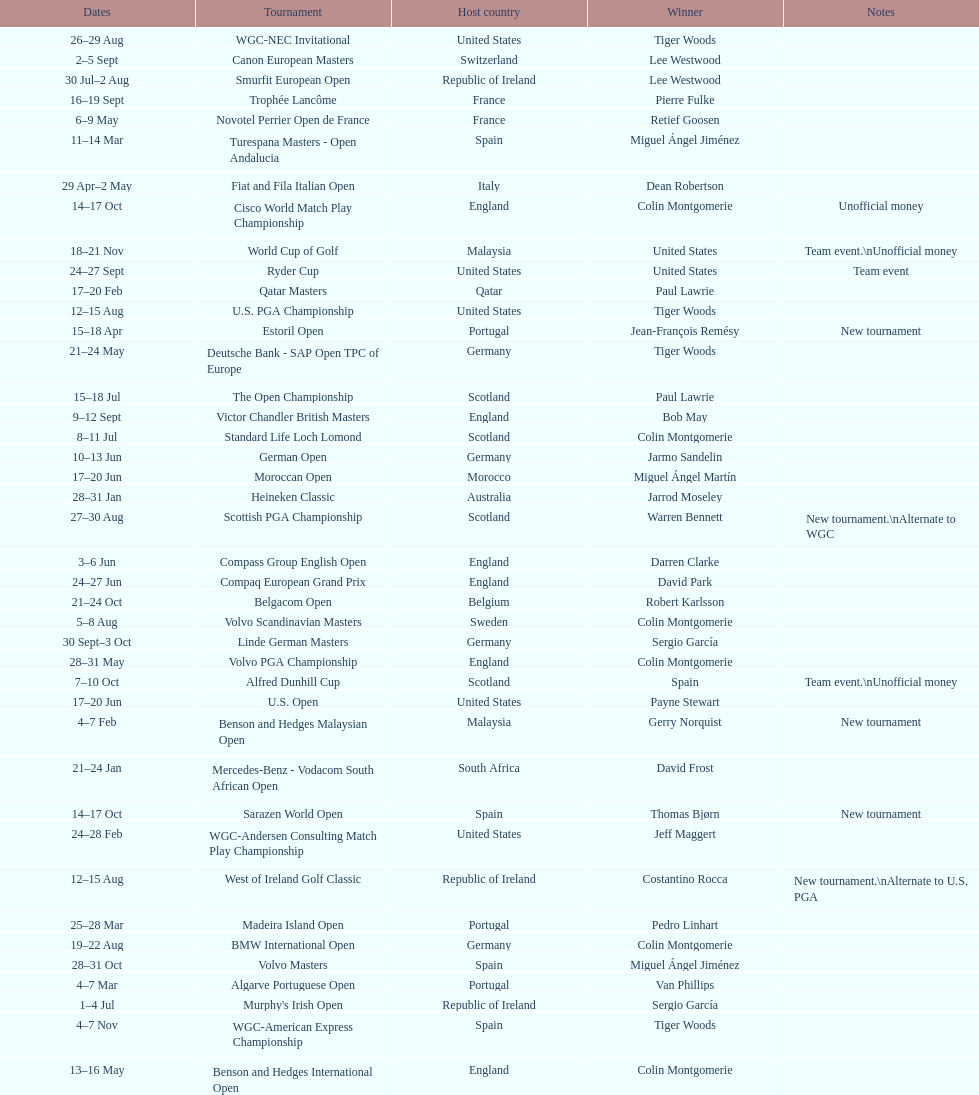Which tournament was later, volvo pga or algarve portuguese open? Volvo PGA. 